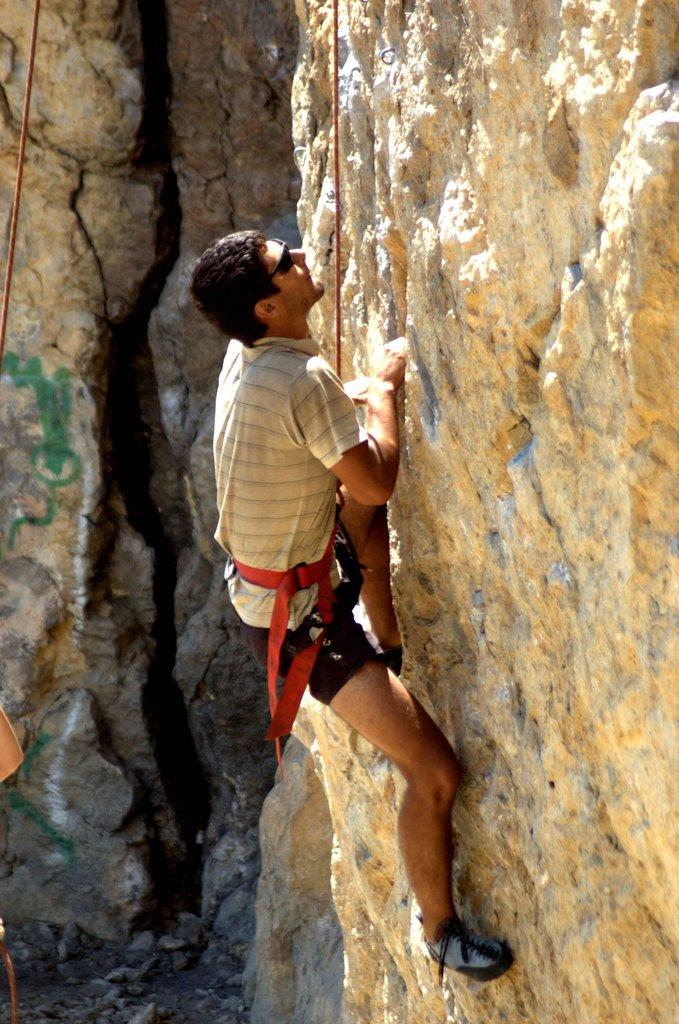Who is the main subject in the image? There is a man in the image. What activity is the man engaged in? The man is doing hill climbing. What type of wrist support is the man using while hill climbing in the image? There is no wrist support visible in the image, as the man is doing hill climbing. Can you see a ship in the background of the image? There is no ship present in the image; it features a man hill climbing. 